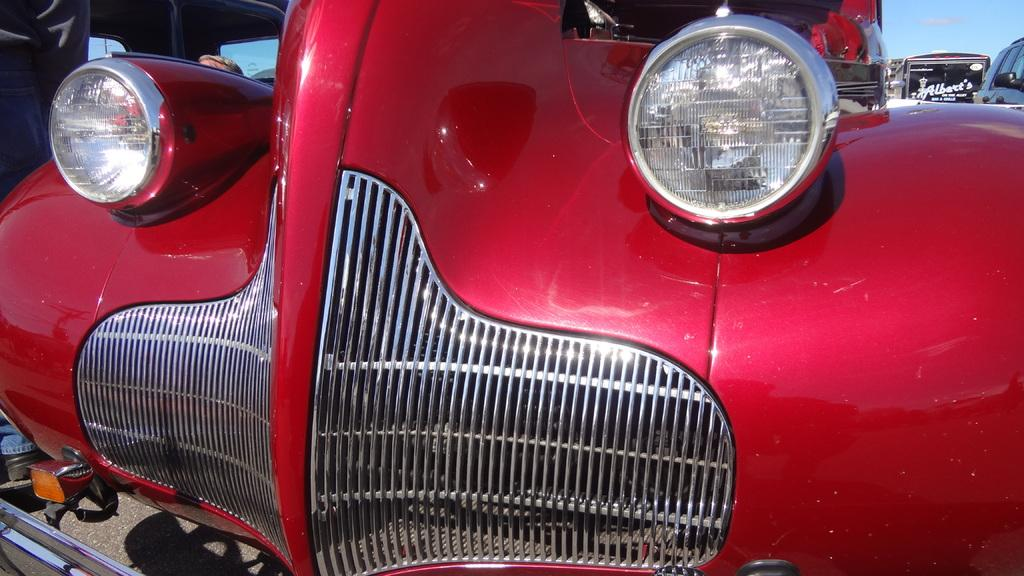What color is the vehicle on the road in the image? The vehicle on the road is red. Are there any other vehicles visible in the image? Yes, there are other vehicles on the road. What can be seen in the sky in the image? There are clouds in the sky, and the sky is blue. What type of news can be heard coming from the vehicle in the image? There is no indication in the image that the vehicle is broadcasting any news, so it cannot be determined from the picture. 